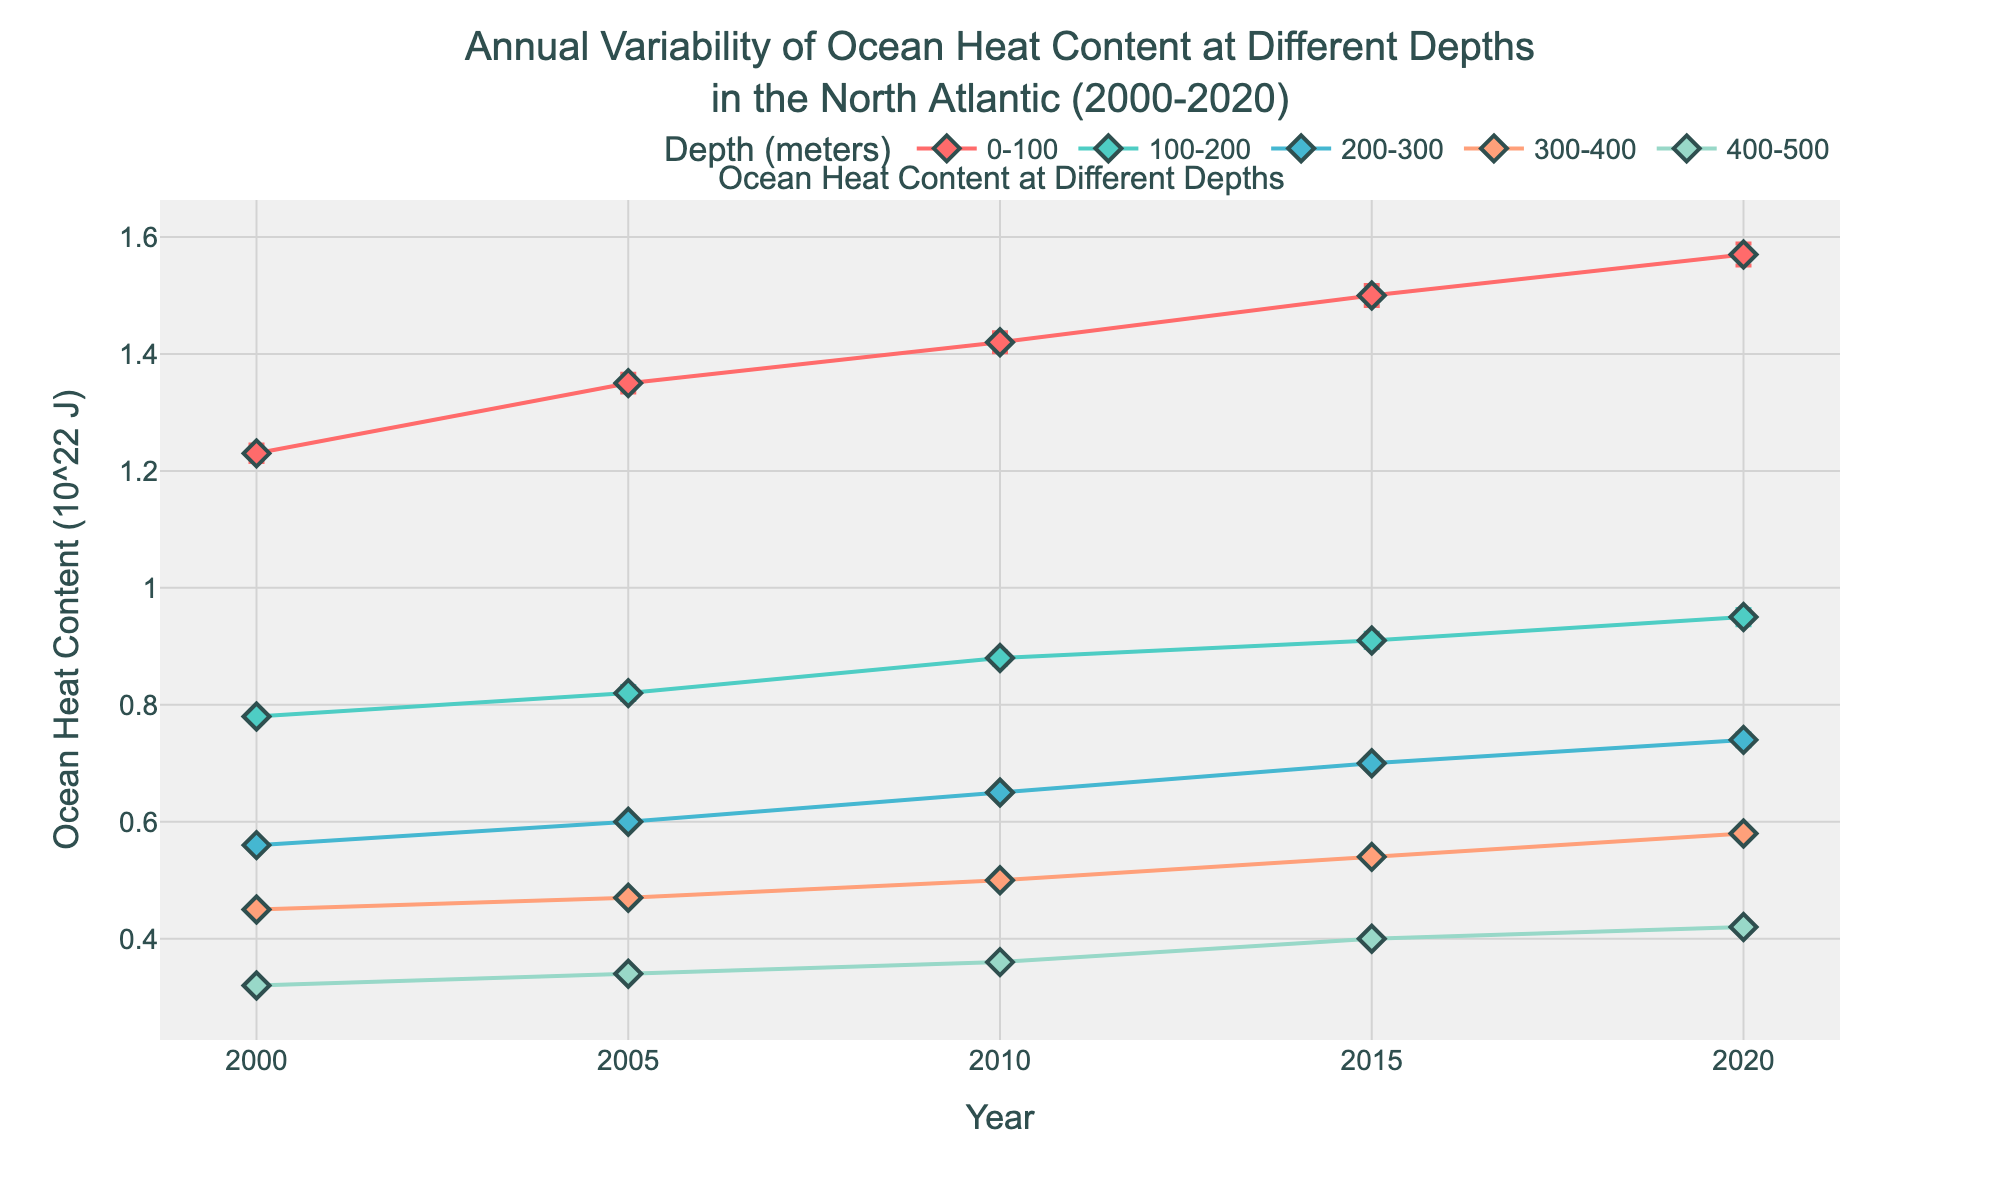What's the title of the figure? The title of the figure is typically displayed at the top and summarizes the main topic. In this case, it reads "Annual Variability of Ocean Heat Content at Different Depths in the North Atlantic (2000-2020)".
Answer: Annual Variability of Ocean Heat Content at Different Depths in the North Atlantic (2000-2020) What is the depth range with the highest mean ocean heat content in 2020? To determine the depth range with the highest mean ocean heat content in 2020, locate the data points for 2020 and identify the highest value. The highest value is at the depth range of 0-100 meters.
Answer: 0-100 meters How does the mean ocean heat content of 300-400 meters depth in 2015 compare with that in 2010? To compare the mean ocean heat content at 300-400 meters depth in 2015 and 2010, locate the values for these years. In 2010, it is 0.50 (10^22 J); in 2015, it is 0.54 (10^22 J). Thus, there is an increase from 2010 to 2015.
Answer: The mean ocean heat content increased Which depth range has the smallest error margin in 2020? To find the depth range with the smallest error margin in 2020, check each depth’s error margin in 2020 and compare. The smallest error margin is 0.06 (10^21 J), corresponding to the depth range of 400-500 meters.
Answer: 400-500 meters What is the overall trend in mean ocean heat content from 2000 to 2020 for the 0-100 meters depth range? Analyzing the 0-100 meters depth range from 2000 to 2020, the values show a steady increase over the years (2000: 1.23, 2005: 1.35, 2010: 1.42, 2015: 1.50, 2020: 1.57).
Answer: Increasing What was the mean ocean heat content at 100-200 meters depth in 2000 compared to 2010? To compare the mean ocean heat content at 100-200 meters depth between 2000 and 2010, check the values which are 0.78 (10^22 J) in 2000 and 0.88 (10^22 J) in 2010.
Answer: The mean ocean heat content increased What is the difference in mean ocean heat content between 0-100 meters and 400-500 meters depths in 2000? The mean ocean heat content for 0-100 meters depth in 2000 is 1.23 (10^22 J) and for 400-500 meters it is 0.32 (10^22 J). The difference is 1.23 - 0.32 = 0.91 (10^22 J).
Answer: 0.91 (10^22 J) Which year shows the highest overall mean ocean heat content across all depth ranges? Looking at all depth ranges from 2000 to 2020, 2020 has the highest values across most depth ranges, indicating overall highest mean ocean heat content.
Answer: 2020 For the depth range 200-300 meters, was the mean ocean heat content higher in 2005 or 2015? Comparing the values for the depth range 200-300 meters, in 2005 it is 0.60 (10^22 J) and in 2015 it is 0.70 (10^22 J), hence 2015 has a higher value.
Answer: 2015 How does the error margin change with increasing depth in 2020? Examining the error margins for each depth in the year 2020: 0–100 m (0.19), 100–200 m (0.14), 200–300 m (0.11), 300–400 m (0.08), 400–500 m (0.06). The error margin generally decreases with increasing depth.
Answer: Decreases 